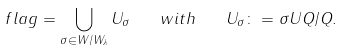<formula> <loc_0><loc_0><loc_500><loc_500>\ f l a g = \bigcup _ { \sigma \in W / W _ { \lambda } } U _ { \sigma } \quad w i t h \quad U _ { \sigma } \colon = \sigma U Q / Q .</formula> 